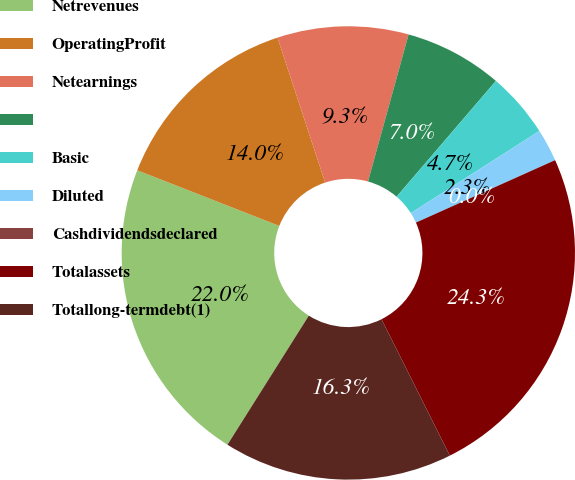Convert chart. <chart><loc_0><loc_0><loc_500><loc_500><pie_chart><fcel>Netrevenues<fcel>OperatingProfit<fcel>Netearnings<fcel>Unnamed: 3<fcel>Basic<fcel>Diluted<fcel>Cashdividendsdeclared<fcel>Totalassets<fcel>Totallong-termdebt(1)<nl><fcel>21.99%<fcel>14.0%<fcel>9.34%<fcel>7.0%<fcel>4.67%<fcel>2.33%<fcel>0.0%<fcel>24.32%<fcel>16.34%<nl></chart> 